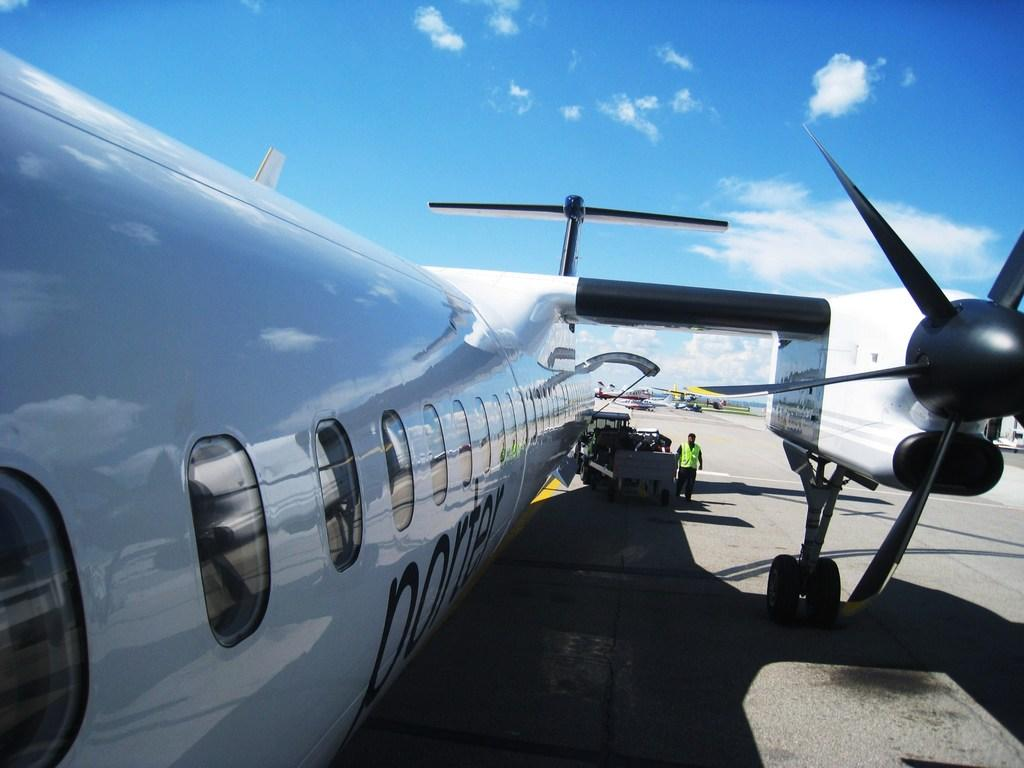What is the main subject of the picture? The main subject of the picture is an airplane. Can you describe the person in the picture? There is a person on a path in the picture. What else can be seen in the picture besides the airplane and the person? There are other vehicles behind the airplane. What is visible in the sky in the picture? The sky is visible in the picture. How many kittens are sitting in the basket in the picture? There is no basket or kittens present in the image. What type of cough does the person on the path have in the picture? There is no indication of a cough or any medical condition in the image. 